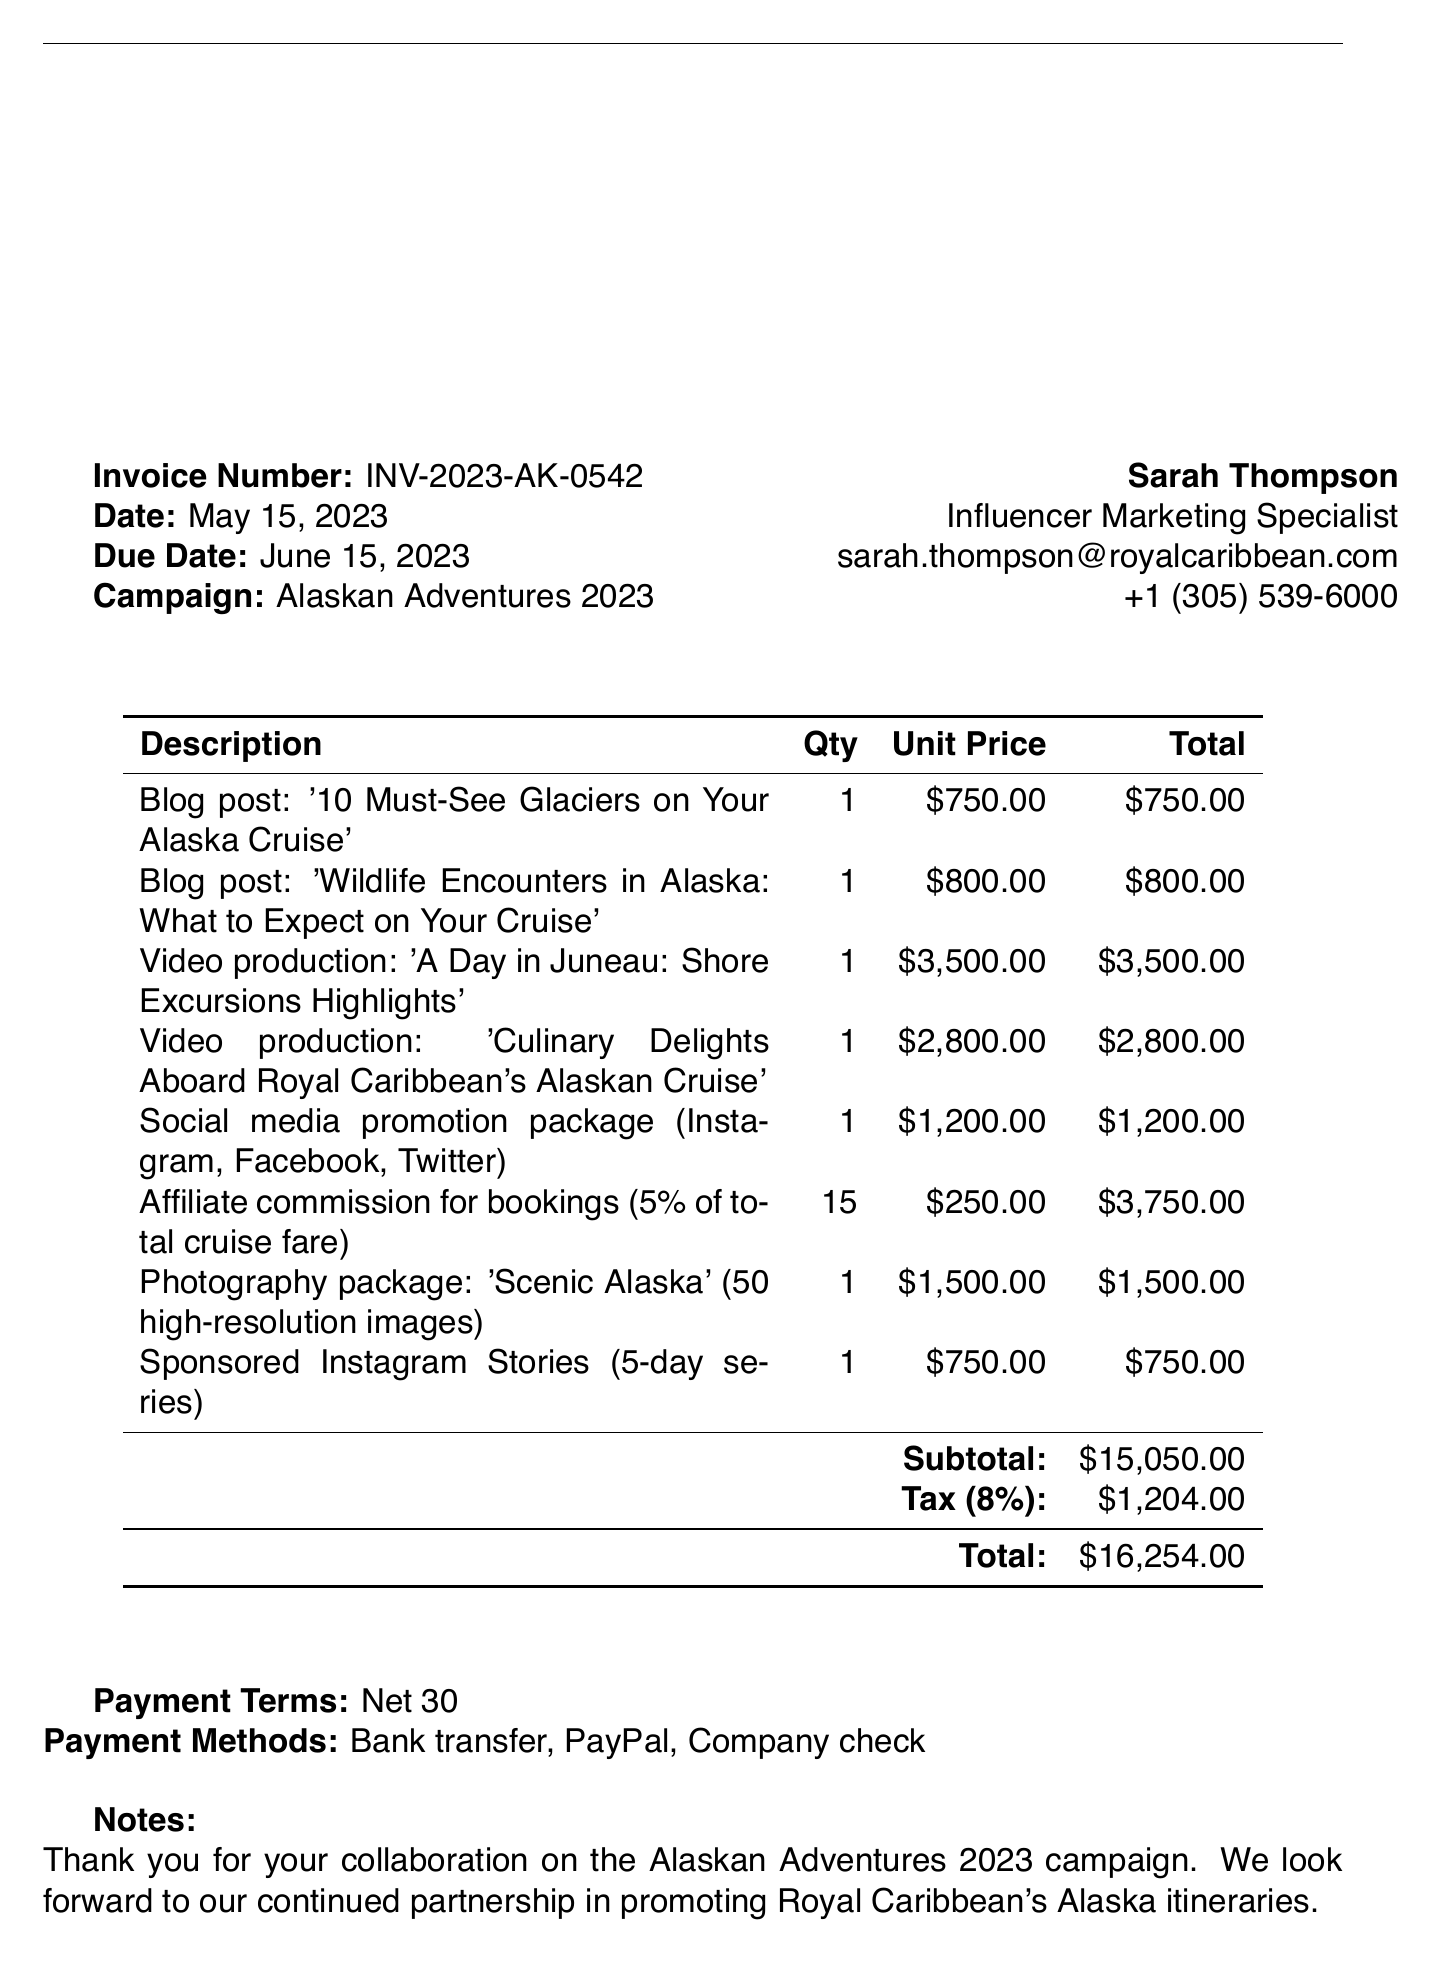What is the invoice number? The invoice number is provided in the document as a unique identifier for the transaction.
Answer: INV-2023-AK-0542 What is the due date for the invoice? The due date indicates when the payment for the invoice should be made.
Answer: June 15, 2023 Who is the contact person for this invoice? The contact person is shown in the document with their details for further communication.
Answer: Sarah Thompson What is the subtotal amount before tax? The subtotal is the total of all items before adding tax, as specified in the invoice.
Answer: $15,050.00 What is the total amount after tax? The total amount includes the subtotal and the tax calculated in the invoice.
Answer: $16,254.00 How many blog posts are listed in the invoice? This requires counting the blog post items specified in the items section of the invoice.
Answer: 2 What type of social media promotion package is included? The document specifies the channels included in the promotional package for clarity.
Answer: Instagram, Facebook, Twitter What percentage is the affiliate commission based on? The affiliate commission is described in the document as a percentage of the total cruise fare.
Answer: 5% What payment terms are stated in the invoice? The payment terms outline the conditions for payment as mentioned in the invoice.
Answer: Net 30 